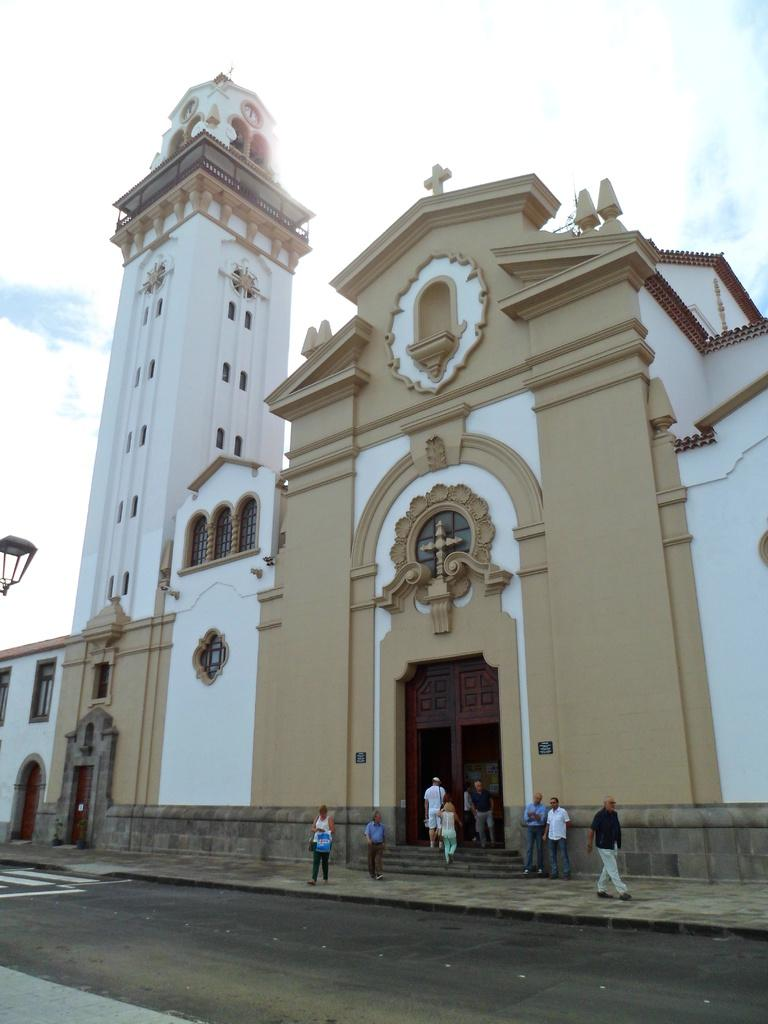What are the people in the image doing? The people in the image are walking. Where are the people walking? The people are walking on a sidewalk and steps. What type of building can be seen in the image? There is a Church building in the image. What else is visible in the image besides the people and the Church building? There is a road in the image. What is the condition of the sky in the image? The sky is visible in the background of the image, and it appears to be cloudy. What type of wheel can be seen on the Church building in the image? There is no wheel present on the Church building in the image. How does the nerve system of the people walking in the image affect their walking speed? The image does not provide information about the nerve systems of the people walking, so it cannot be determined how their nerve systems affect their walking speed. 